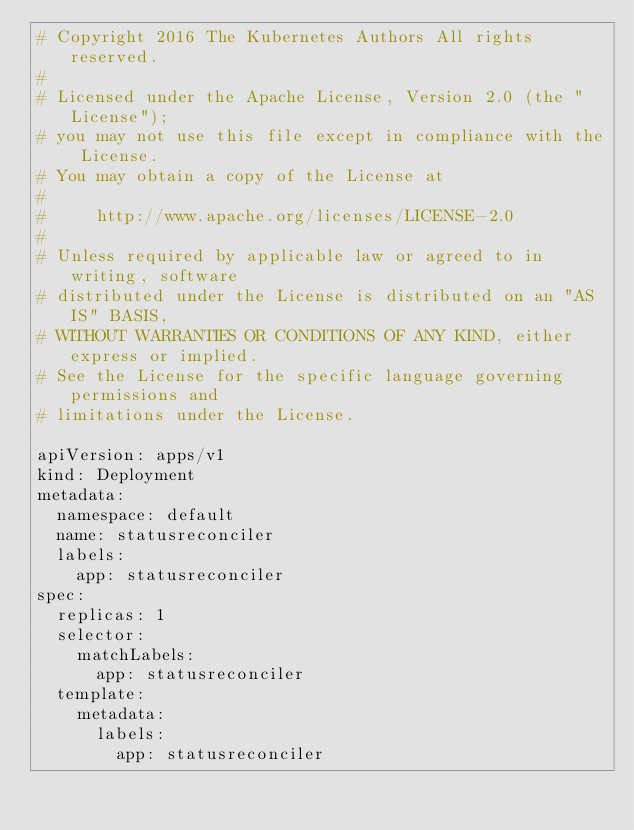Convert code to text. <code><loc_0><loc_0><loc_500><loc_500><_YAML_># Copyright 2016 The Kubernetes Authors All rights reserved.
#
# Licensed under the Apache License, Version 2.0 (the "License");
# you may not use this file except in compliance with the License.
# You may obtain a copy of the License at
#
#     http://www.apache.org/licenses/LICENSE-2.0
#
# Unless required by applicable law or agreed to in writing, software
# distributed under the License is distributed on an "AS IS" BASIS,
# WITHOUT WARRANTIES OR CONDITIONS OF ANY KIND, either express or implied.
# See the License for the specific language governing permissions and
# limitations under the License.

apiVersion: apps/v1
kind: Deployment
metadata:
  namespace: default
  name: statusreconciler
  labels:
    app: statusreconciler
spec:
  replicas: 1
  selector:
    matchLabels:
      app: statusreconciler
  template:
    metadata:
      labels:
        app: statusreconciler</code> 